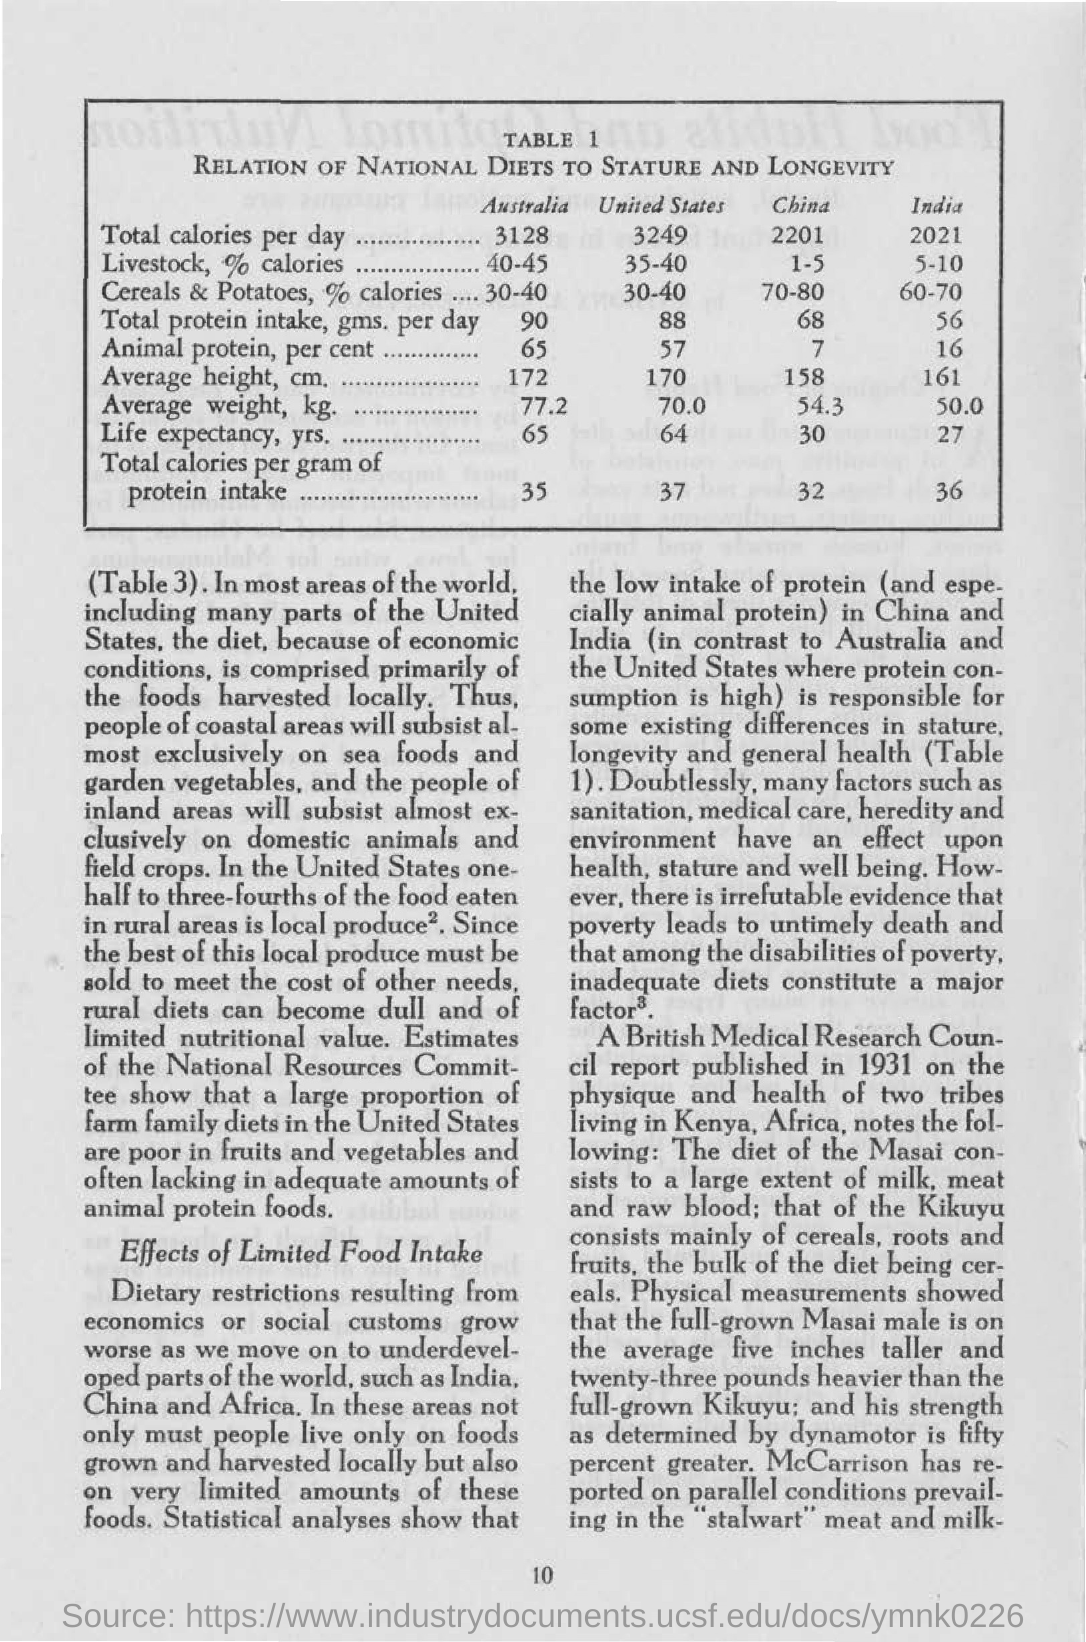What are the total calories per day for "australia"?
Your answer should be very brief. 3128. What are the total calories per day for "india"?
Provide a short and direct response. 2021. What are the total calories per gram of protein intake for "united states"?
Provide a succinct answer. 37. What are the total calories per gram of protein intake for "china"?
Your response must be concise. 32. 